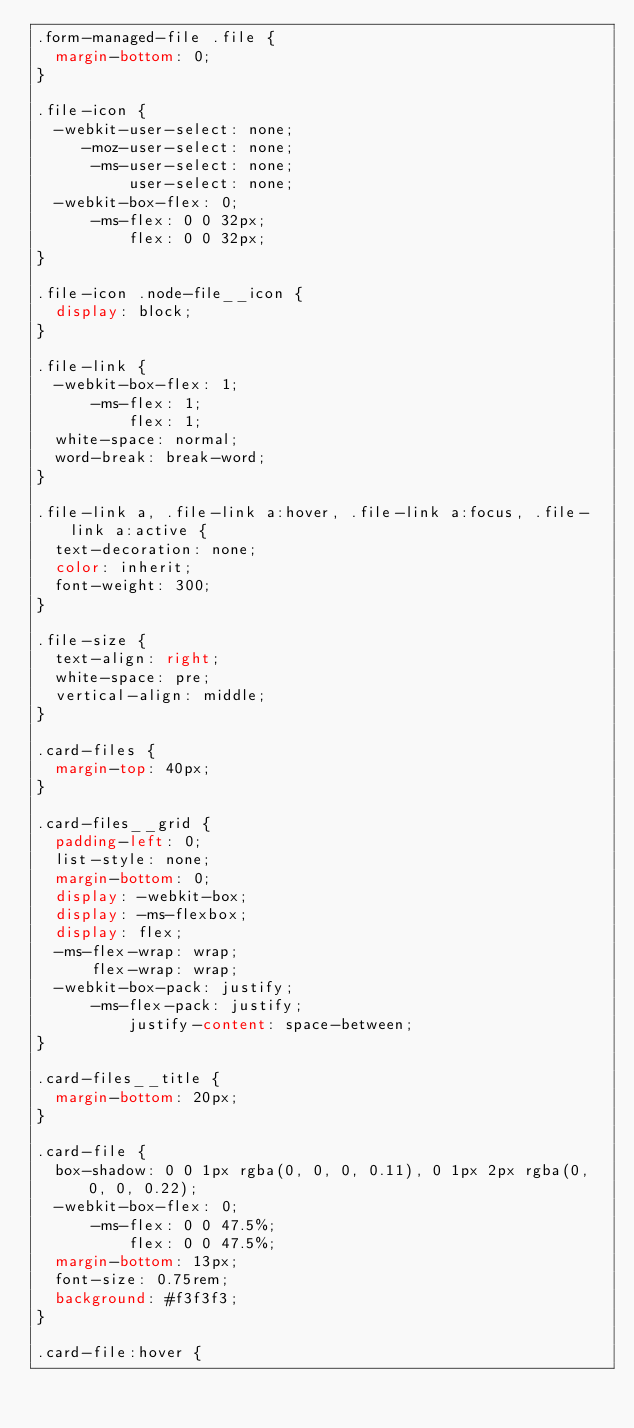<code> <loc_0><loc_0><loc_500><loc_500><_CSS_>.form-managed-file .file {
  margin-bottom: 0;
}

.file-icon {
  -webkit-user-select: none;
     -moz-user-select: none;
      -ms-user-select: none;
          user-select: none;
  -webkit-box-flex: 0;
      -ms-flex: 0 0 32px;
          flex: 0 0 32px;
}

.file-icon .node-file__icon {
  display: block;
}

.file-link {
  -webkit-box-flex: 1;
      -ms-flex: 1;
          flex: 1;
  white-space: normal;
  word-break: break-word;
}

.file-link a, .file-link a:hover, .file-link a:focus, .file-link a:active {
  text-decoration: none;
  color: inherit;
  font-weight: 300;
}

.file-size {
  text-align: right;
  white-space: pre;
  vertical-align: middle;
}

.card-files {
  margin-top: 40px;
}

.card-files__grid {
  padding-left: 0;
  list-style: none;
  margin-bottom: 0;
  display: -webkit-box;
  display: -ms-flexbox;
  display: flex;
  -ms-flex-wrap: wrap;
      flex-wrap: wrap;
  -webkit-box-pack: justify;
      -ms-flex-pack: justify;
          justify-content: space-between;
}

.card-files__title {
  margin-bottom: 20px;
}

.card-file {
  box-shadow: 0 0 1px rgba(0, 0, 0, 0.11), 0 1px 2px rgba(0, 0, 0, 0.22);
  -webkit-box-flex: 0;
      -ms-flex: 0 0 47.5%;
          flex: 0 0 47.5%;
  margin-bottom: 13px;
  font-size: 0.75rem;
  background: #f3f3f3;
}

.card-file:hover {</code> 